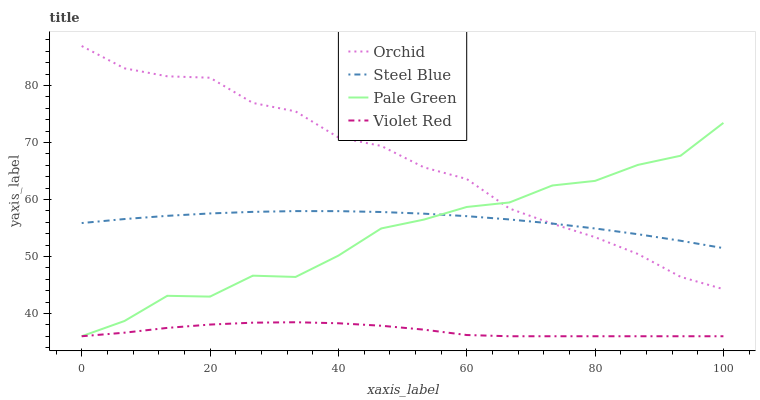Does Violet Red have the minimum area under the curve?
Answer yes or no. Yes. Does Orchid have the maximum area under the curve?
Answer yes or no. Yes. Does Pale Green have the minimum area under the curve?
Answer yes or no. No. Does Pale Green have the maximum area under the curve?
Answer yes or no. No. Is Steel Blue the smoothest?
Answer yes or no. Yes. Is Pale Green the roughest?
Answer yes or no. Yes. Is Pale Green the smoothest?
Answer yes or no. No. Is Steel Blue the roughest?
Answer yes or no. No. Does Violet Red have the lowest value?
Answer yes or no. Yes. Does Steel Blue have the lowest value?
Answer yes or no. No. Does Orchid have the highest value?
Answer yes or no. Yes. Does Pale Green have the highest value?
Answer yes or no. No. Is Violet Red less than Steel Blue?
Answer yes or no. Yes. Is Orchid greater than Violet Red?
Answer yes or no. Yes. Does Pale Green intersect Violet Red?
Answer yes or no. Yes. Is Pale Green less than Violet Red?
Answer yes or no. No. Is Pale Green greater than Violet Red?
Answer yes or no. No. Does Violet Red intersect Steel Blue?
Answer yes or no. No. 